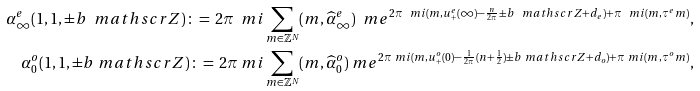<formula> <loc_0><loc_0><loc_500><loc_500>\alpha ^ { e } _ { \infty } ( 1 , 1 , \pm b { \ m a t h s c r { Z } } ) \, \colon = \, 2 \pi \ m i \sum _ { m \in \mathbb { Z } ^ { N } } ( m , \widehat { \alpha } ^ { e } _ { \infty } ) \ m e ^ { 2 \pi \ m i ( m , u ^ { e } _ { + } ( \infty ) - \frac { n } { 2 \pi } \pm b { \ m a t h s c r { Z } } + d _ { e } ) + \pi \ m i ( m , \tau ^ { e } m ) } , \\ \alpha ^ { o } _ { 0 } ( 1 , 1 , \pm b { \ m a t h s c r { Z } } ) \, \colon = \, 2 \pi \ m i \sum _ { m \in \mathbb { Z } ^ { N } } ( m , \widehat { \alpha } ^ { o } _ { 0 } ) \ m e ^ { 2 \pi \ m i ( m , u ^ { o } _ { + } ( 0 ) - \frac { 1 } { 2 \pi } ( n + \frac { 1 } { 2 } ) \pm b { \ m a t h s c r { Z } } + d _ { o } ) + \pi \ m i ( m , \tau ^ { o } m ) } ,</formula> 